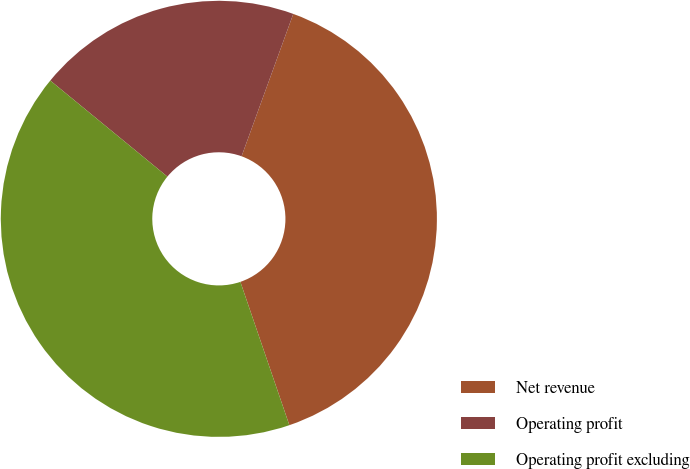<chart> <loc_0><loc_0><loc_500><loc_500><pie_chart><fcel>Net revenue<fcel>Operating profit<fcel>Operating profit excluding<nl><fcel>39.22%<fcel>19.61%<fcel>41.18%<nl></chart> 